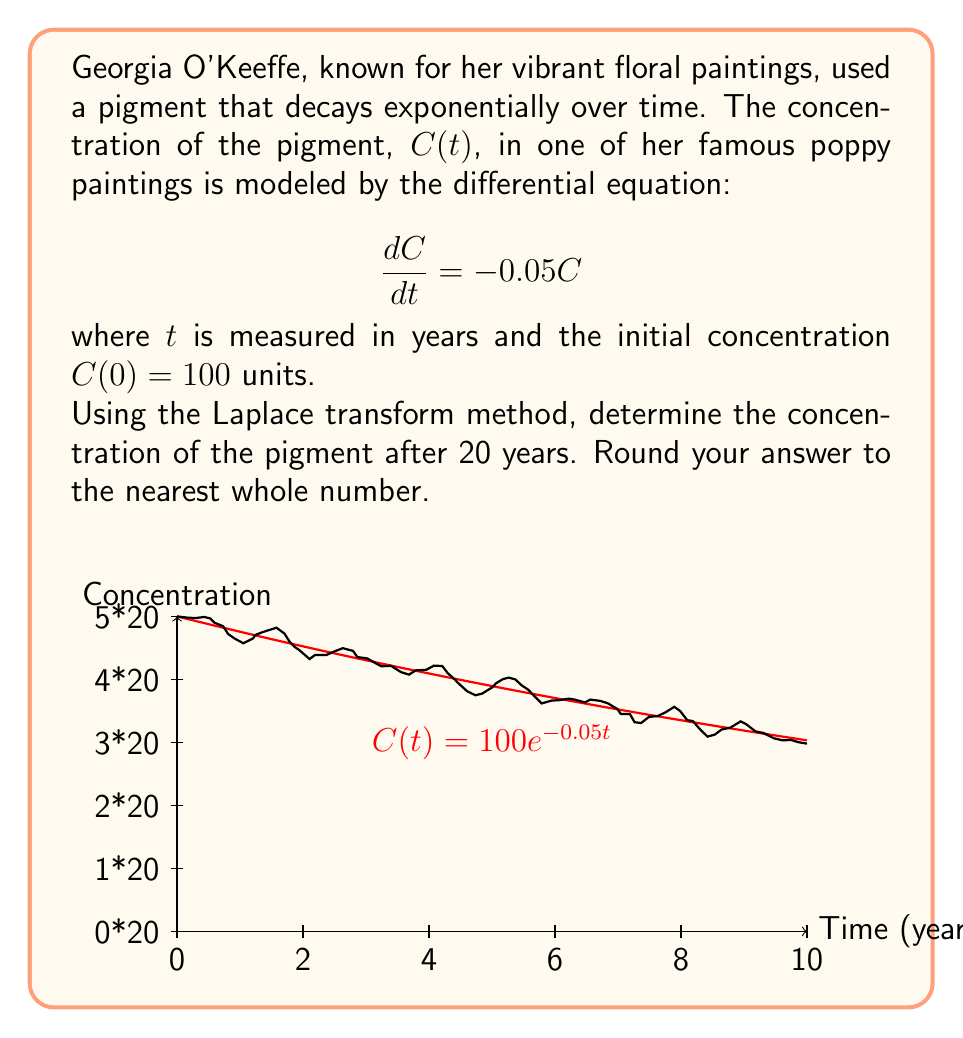Teach me how to tackle this problem. Let's solve this problem step by step using the Laplace transform method:

1) The given differential equation is:
   $$\frac{dC}{dt} = -0.05C$$
   with initial condition $C(0) = 100$

2) Take the Laplace transform of both sides:
   $$\mathcal{L}\left\{\frac{dC}{dt}\right\} = \mathcal{L}\{-0.05C\}$$

3) Using the Laplace transform properties:
   $$sC(s) - C(0) = -0.05C(s)$$

4) Substitute the initial condition:
   $$sC(s) - 100 = -0.05C(s)$$

5) Rearrange the equation:
   $$(s + 0.05)C(s) = 100$$

6) Solve for $C(s)$:
   $$C(s) = \frac{100}{s + 0.05}$$

7) This is in the form of $\frac{A}{s + a}$, which has the inverse Laplace transform:
   $$C(t) = Ae^{-at}$$

8) Therefore, the solution is:
   $$C(t) = 100e^{-0.05t}$$

9) To find the concentration after 20 years, substitute $t = 20$:
   $$C(20) = 100e^{-0.05(20)} \approx 36.79$$

10) Rounding to the nearest whole number:
    $$C(20) \approx 37$$
Answer: 37 units 